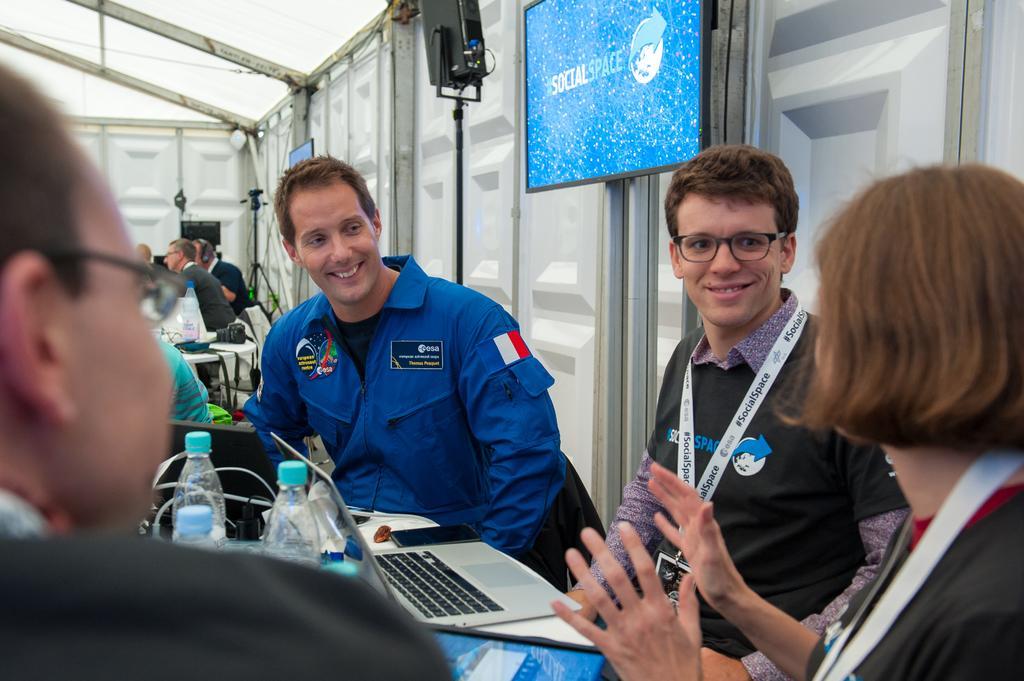Could you give a brief overview of what you see in this image? In this picture I can see people with a smile sitting on the chair. I can see electronic devices on the table. I can see the screen. 